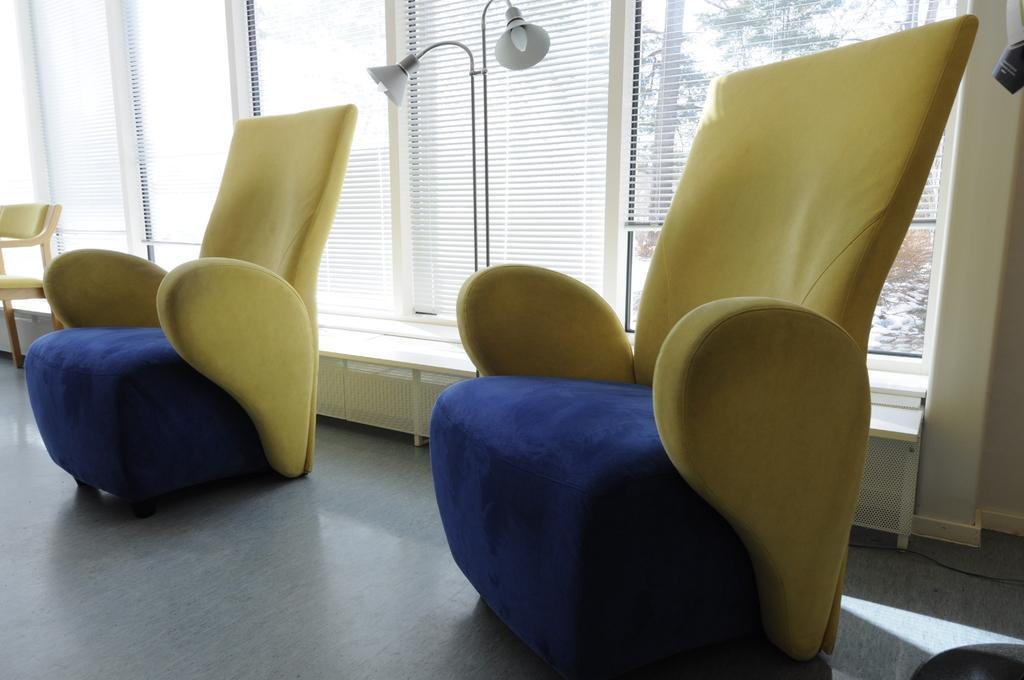How would you summarize this image in a sentence or two? In this image we can see chairs, lamps, windows and behind the windows we can see some trees. 